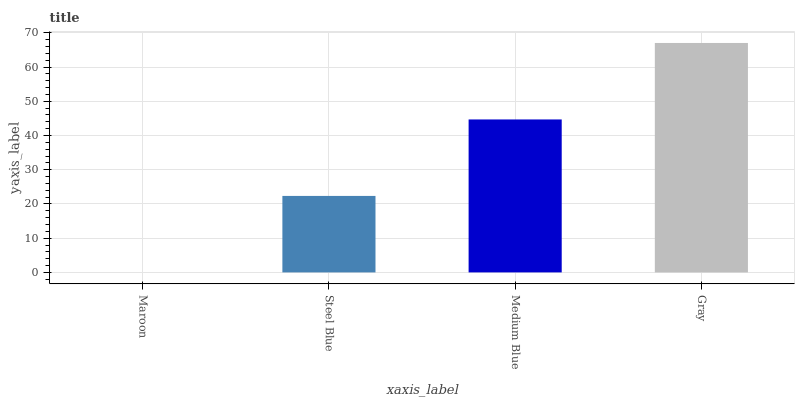Is Steel Blue the minimum?
Answer yes or no. No. Is Steel Blue the maximum?
Answer yes or no. No. Is Steel Blue greater than Maroon?
Answer yes or no. Yes. Is Maroon less than Steel Blue?
Answer yes or no. Yes. Is Maroon greater than Steel Blue?
Answer yes or no. No. Is Steel Blue less than Maroon?
Answer yes or no. No. Is Medium Blue the high median?
Answer yes or no. Yes. Is Steel Blue the low median?
Answer yes or no. Yes. Is Steel Blue the high median?
Answer yes or no. No. Is Medium Blue the low median?
Answer yes or no. No. 